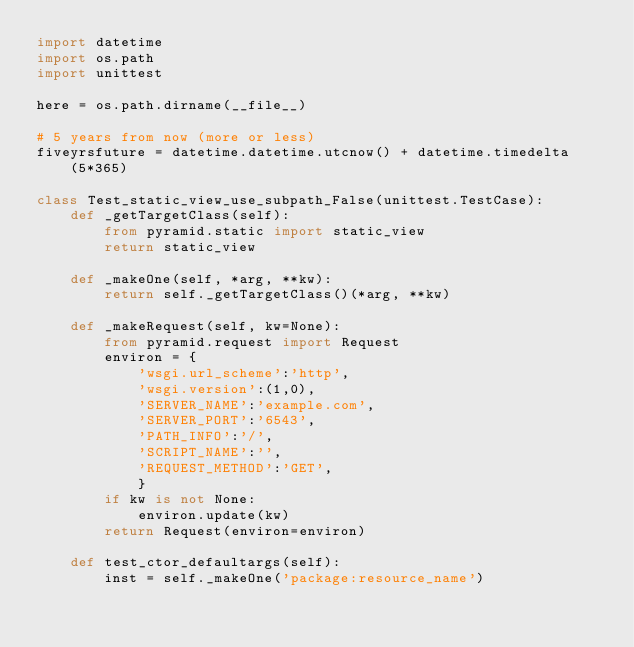Convert code to text. <code><loc_0><loc_0><loc_500><loc_500><_Python_>import datetime
import os.path
import unittest

here = os.path.dirname(__file__)

# 5 years from now (more or less)
fiveyrsfuture = datetime.datetime.utcnow() + datetime.timedelta(5*365)

class Test_static_view_use_subpath_False(unittest.TestCase):
    def _getTargetClass(self):
        from pyramid.static import static_view
        return static_view

    def _makeOne(self, *arg, **kw):
        return self._getTargetClass()(*arg, **kw)

    def _makeRequest(self, kw=None):
        from pyramid.request import Request
        environ = {
            'wsgi.url_scheme':'http',
            'wsgi.version':(1,0),
            'SERVER_NAME':'example.com',
            'SERVER_PORT':'6543',
            'PATH_INFO':'/',
            'SCRIPT_NAME':'',
            'REQUEST_METHOD':'GET',
            }
        if kw is not None:
            environ.update(kw)
        return Request(environ=environ)

    def test_ctor_defaultargs(self):
        inst = self._makeOne('package:resource_name')</code> 